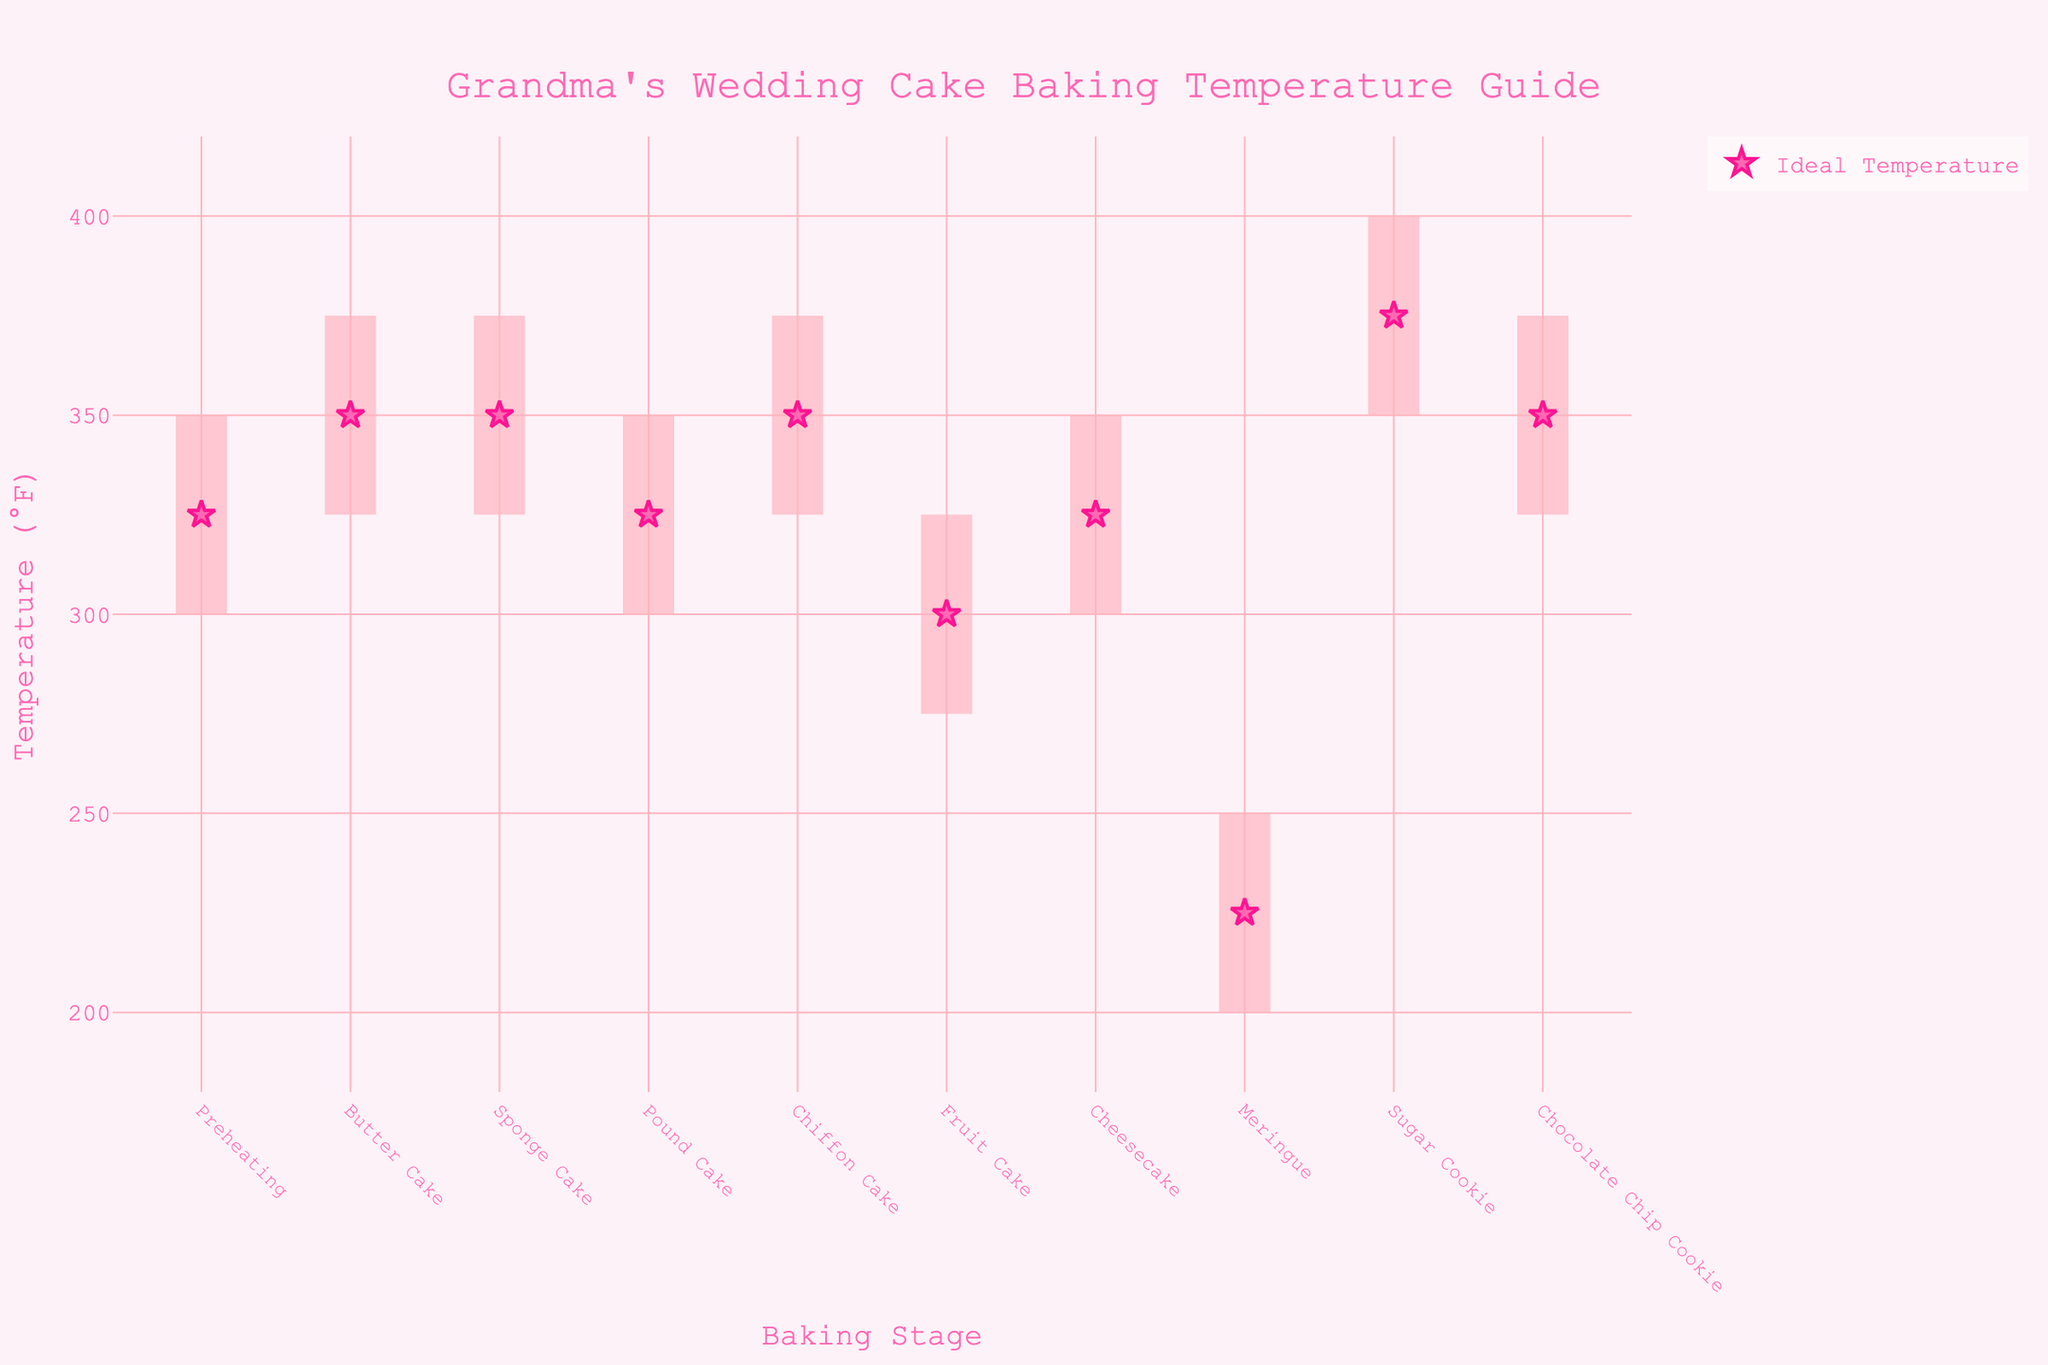What's the title of the figure? The title of the figure is the bold text at the top, which usually provides context for the data being presented.
Answer: Grandma's Wedding Cake Baking Temperature Guide What's the range of temperatures for baking a Sugar Cookie? The range of temperatures is represented by the three data points: Min Temperature, Ideal Temperature, and Max Temperature for Sugar Cookie.
Answer: 350°F to 400°F Which cake type requires the lowest minimum baking temperature? To determine this, compare the minimum temperatures of all the cake types listed and identify the lowest value. Meringue has the lowest minimum temperature.
Answer: Meringue What’s the ideal baking temperature for a Chiffon Cake? Find the marked ideal temperature (usually denoted by a unique marker) for Chiffon Cake on the figure.
Answer: 350°F How many cake types have an ideal baking temperature of 350°F? Count the number of stages where the ideal temperature marker is at 350°F. These include Butter Cake, Sponge Cake, Chiffon Cake, Chocolate Chip Cookie, and potentially others based on the figure's specific data.
Answer: 5 Which cake types share the same temperature range of 300°F to 350°F? Identify the stages with a Min Temperature of 300°F and a Max Temperature of 350°F, and list them.
Answer: Cheesecake, Pound Cake What is the temperature range for baking a Cheesecake? Identify the data points associated with the Cheesecake stage: Min Temperature, Ideal Temperature, and Max Temperature.
Answer: 300°F to 350°F What's the difference between the maximum temperature for baking a Meringue and a Sugar Cookie? Subtract the maximum temperature for Meringue from the maximum temperature for Sugar Cookie: 400°F - 250°F.
Answer: 150°F 